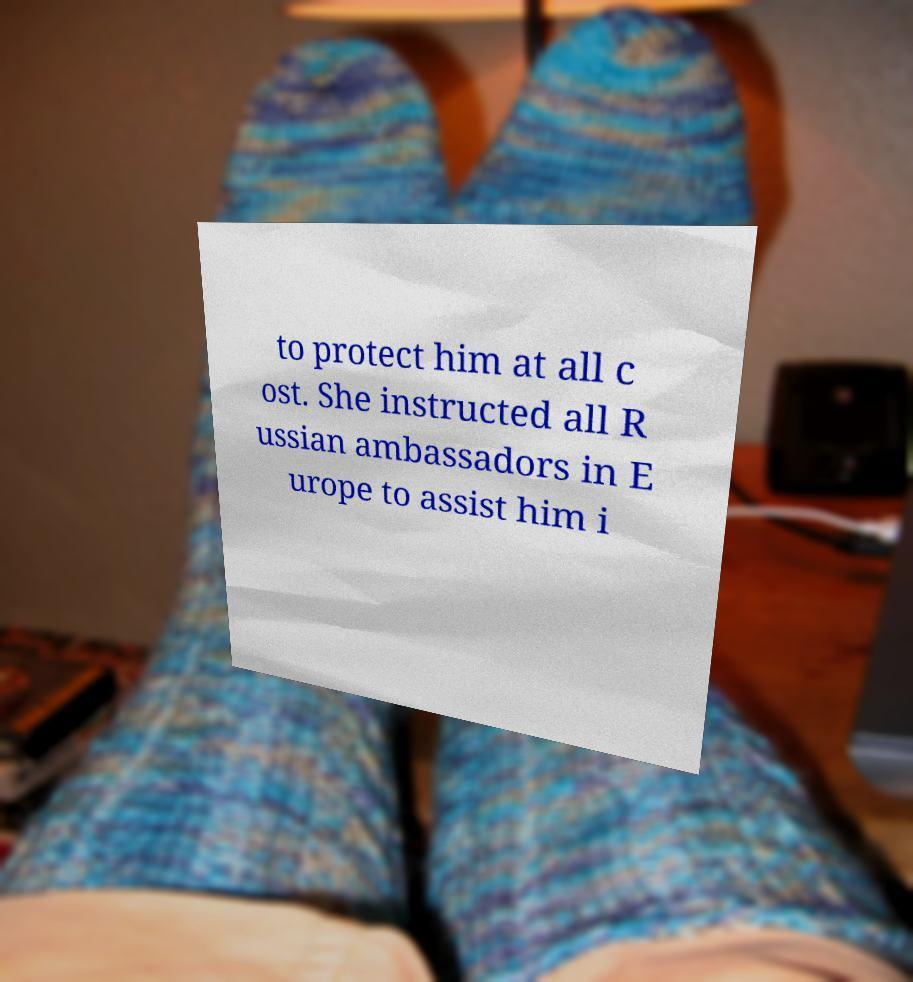Please read and relay the text visible in this image. What does it say? to protect him at all c ost. She instructed all R ussian ambassadors in E urope to assist him i 